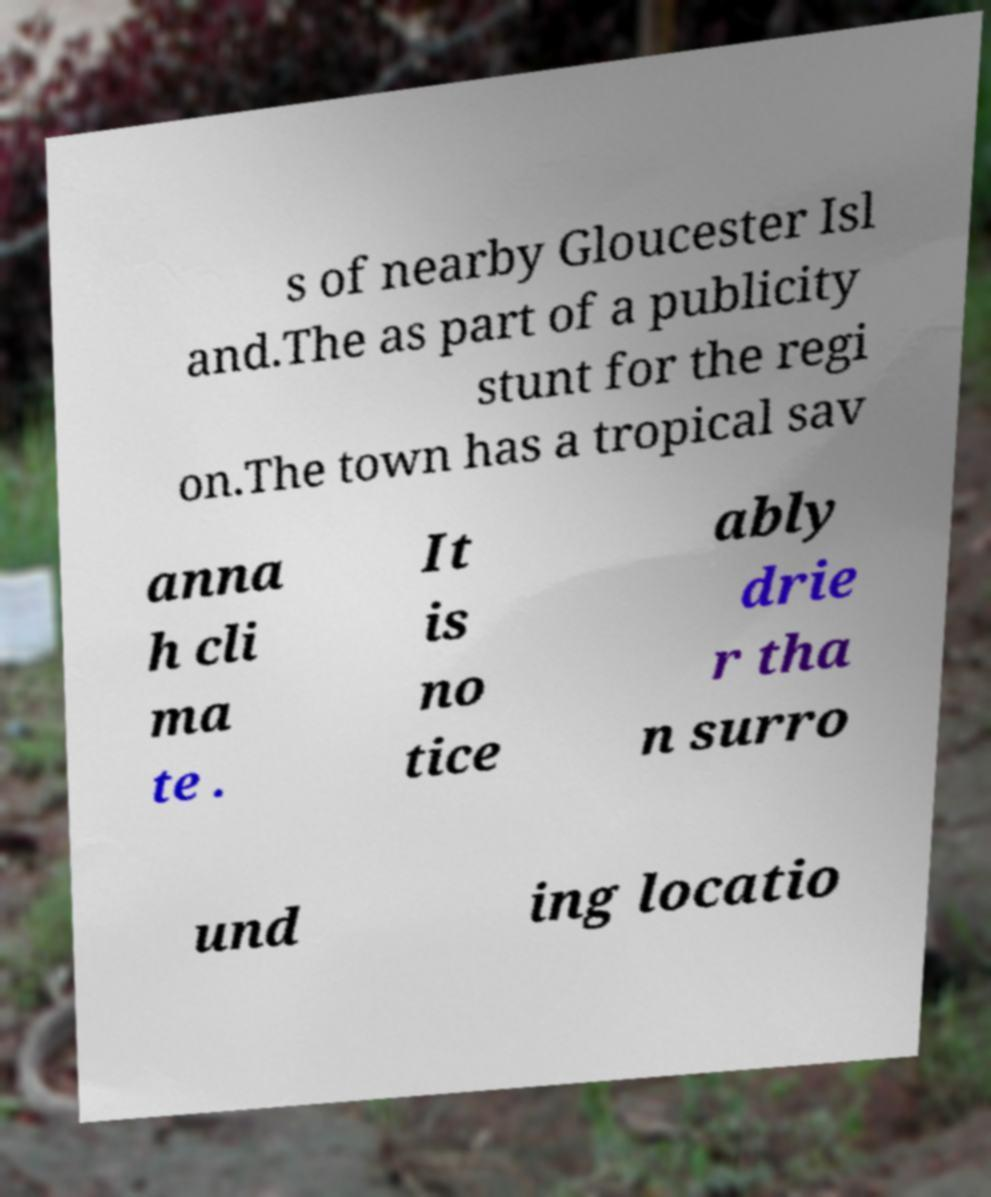Please identify and transcribe the text found in this image. s of nearby Gloucester Isl and.The as part of a publicity stunt for the regi on.The town has a tropical sav anna h cli ma te . It is no tice ably drie r tha n surro und ing locatio 